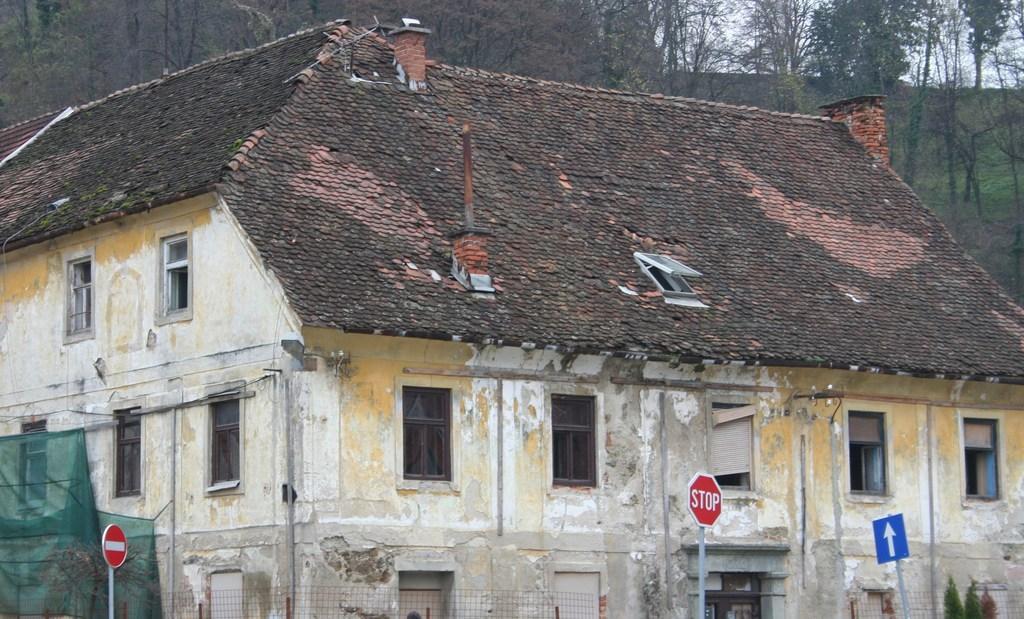In one or two sentences, can you explain what this image depicts? In this image there is a building and we can see boards. In the background there are trees and sky. 